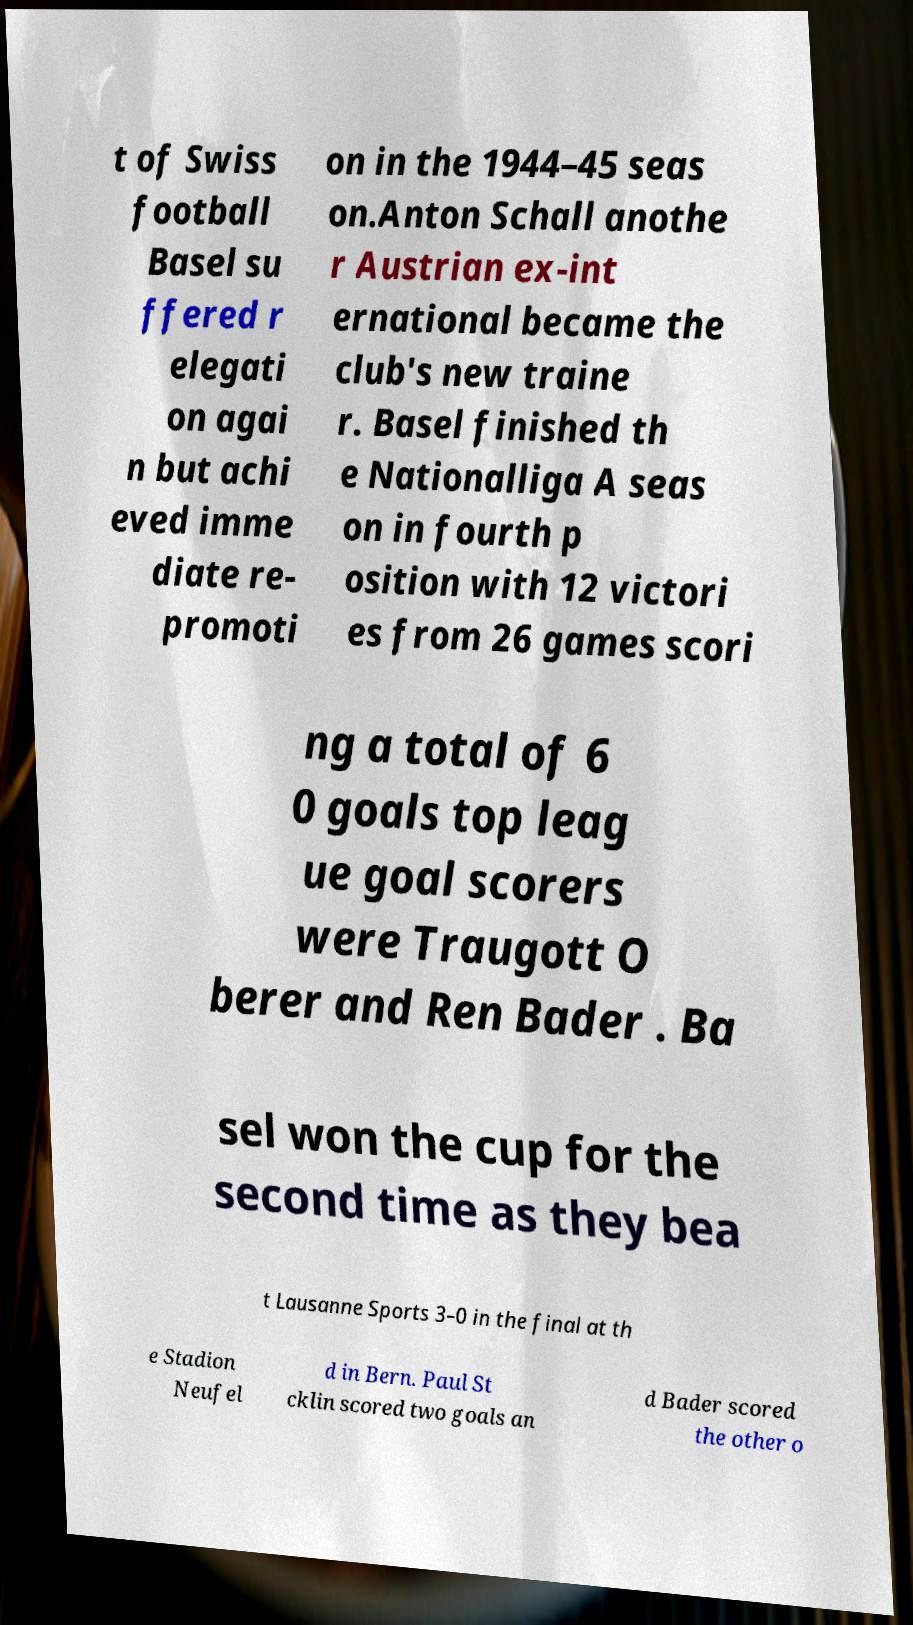I need the written content from this picture converted into text. Can you do that? t of Swiss football Basel su ffered r elegati on agai n but achi eved imme diate re- promoti on in the 1944–45 seas on.Anton Schall anothe r Austrian ex-int ernational became the club's new traine r. Basel finished th e Nationalliga A seas on in fourth p osition with 12 victori es from 26 games scori ng a total of 6 0 goals top leag ue goal scorers were Traugott O berer and Ren Bader . Ba sel won the cup for the second time as they bea t Lausanne Sports 3–0 in the final at th e Stadion Neufel d in Bern. Paul St cklin scored two goals an d Bader scored the other o 